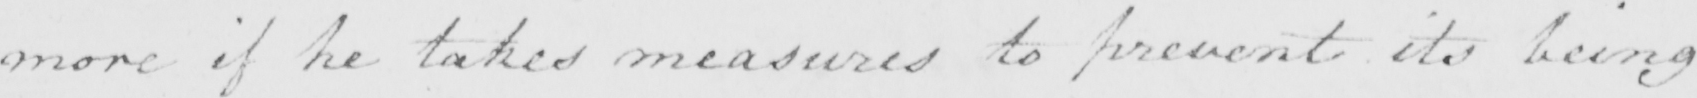Can you read and transcribe this handwriting? more if he takes measures to prevent its being 